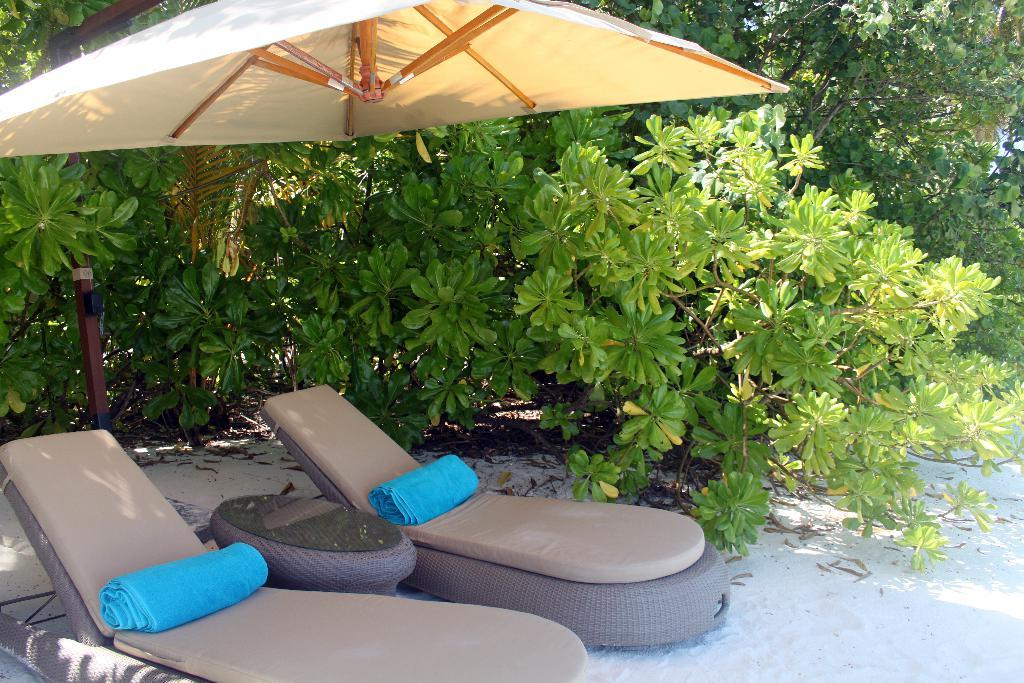What type of furniture is present in the image? There are chairs in the image. What is placed on the chairs? Blue color clothes are on the chairs. What other piece of furniture can be seen in the image? There is a table in the image. What is the color scheme of the image? There is a whiter shade in the image. What type of natural scenery is visible in the image? Trees are visible in the image. What can be observed on the ground in the image? Shadows are present on the ground in the image. Can you tell me where the sack is located in the image? There is no sack present in the image. What type of religious building can be seen in the image? There is no religious building, such as a church, present in the image. 